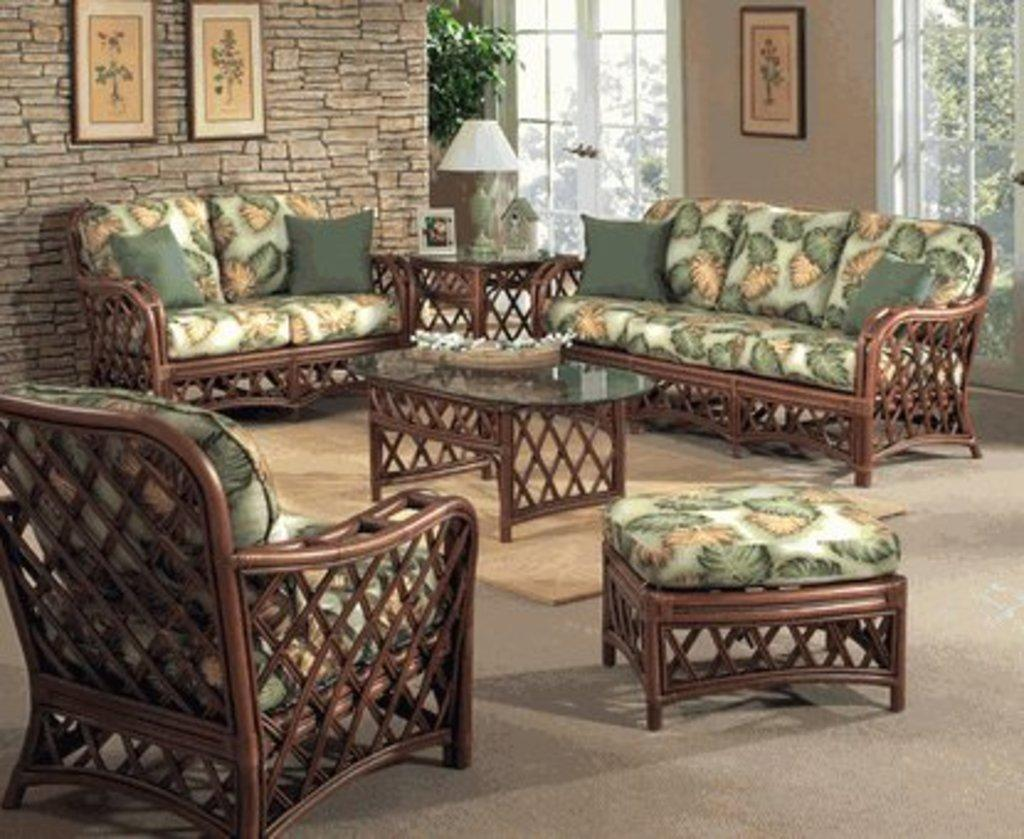What type of structure is visible in the image? There is a brick wall in the image. What can be seen in the brick wall? There are windows in the image. What decorative item is present in the image? There is a photo frame in the image. What type of lighting is visible in the image? There is a lamp in the image. What type of furniture is present in the image? There are sofas in the image. What type of bath can be seen in the image? There is no bath present in the image. How comfortable are the sofas in the image? The comfort level of the sofas cannot be determined from the image alone. 